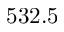<formula> <loc_0><loc_0><loc_500><loc_500>5 3 2 . 5</formula> 